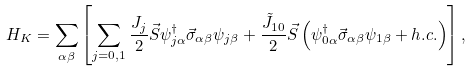<formula> <loc_0><loc_0><loc_500><loc_500>H _ { K } = \sum _ { \alpha \beta } \left [ \sum _ { j = 0 , 1 } \frac { J _ { j } } { 2 } \vec { S } \psi ^ { \dagger } _ { j \alpha } \vec { \sigma } _ { \alpha \beta } \psi _ { j \beta } + \frac { \tilde { J } _ { 1 0 } } { 2 } \vec { S } \left ( \psi ^ { \dagger } _ { 0 \alpha } \vec { \sigma } _ { \alpha \beta } \psi _ { 1 \beta } + h . c . \right ) \right ] ,</formula> 